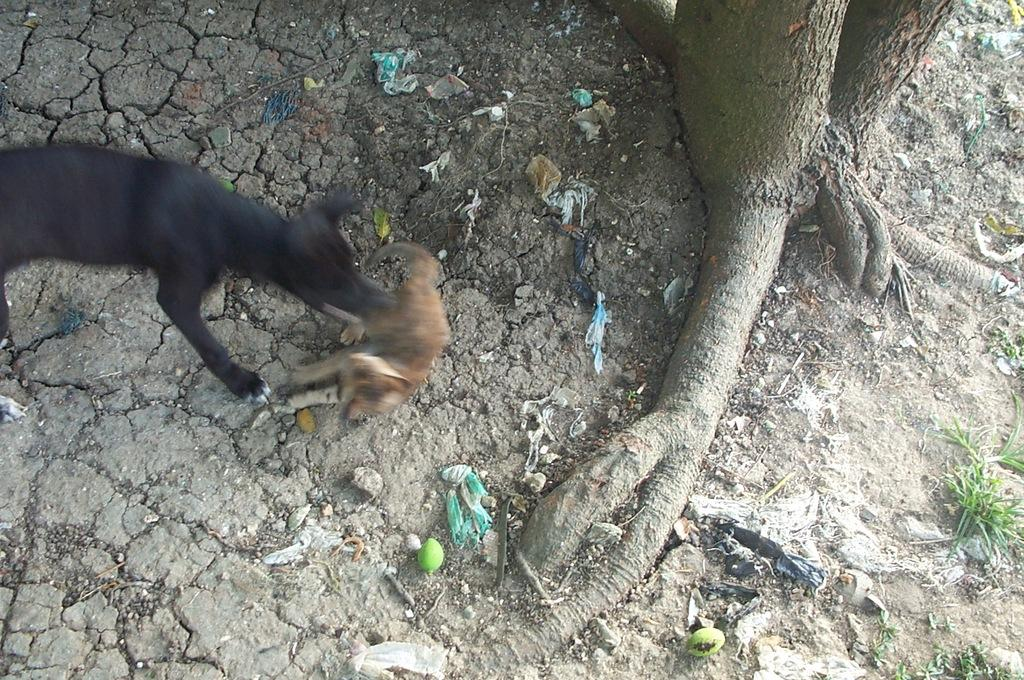What type of animal can be seen in the image? There is a dog in the image. Can you describe the dog's location in the image? The dog is on the ground in the image. What type of vegetation is visible in the image? There is: There is a tree and grass visible in the image. What else can be seen on the ground in the image? There are other objects on the ground in the image. What is the value of the dog's collar in the image? There is no collar visible in the image, so it is not possible to determine its value. 